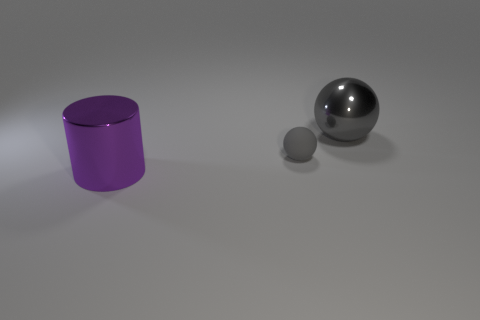Are there any other things that have the same material as the small object?
Your answer should be very brief. No. Is the shape of the gray thing that is on the right side of the small thing the same as the big thing that is on the left side of the small gray object?
Offer a very short reply. No. There is a gray metal thing that is the same size as the purple cylinder; what is its shape?
Provide a short and direct response. Sphere. What number of metallic objects are small gray objects or purple objects?
Keep it short and to the point. 1. Is the tiny gray object that is right of the purple metallic object made of the same material as the big thing that is right of the big metal cylinder?
Keep it short and to the point. No. There is a large thing that is made of the same material as the cylinder; what is its color?
Your answer should be very brief. Gray. Is the number of gray objects to the left of the large ball greater than the number of big purple metal cylinders that are behind the large shiny cylinder?
Ensure brevity in your answer.  Yes. Is there a big blue rubber object?
Offer a very short reply. No. There is a object that is the same color as the large shiny ball; what is it made of?
Your answer should be compact. Rubber. How many things are either gray spheres or big purple shiny cylinders?
Your response must be concise. 3. 